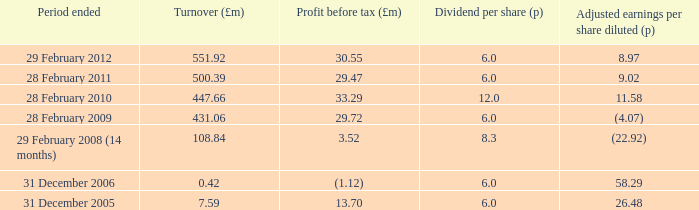What was the turnover when the profit before tax was 29.47? 500.39. 